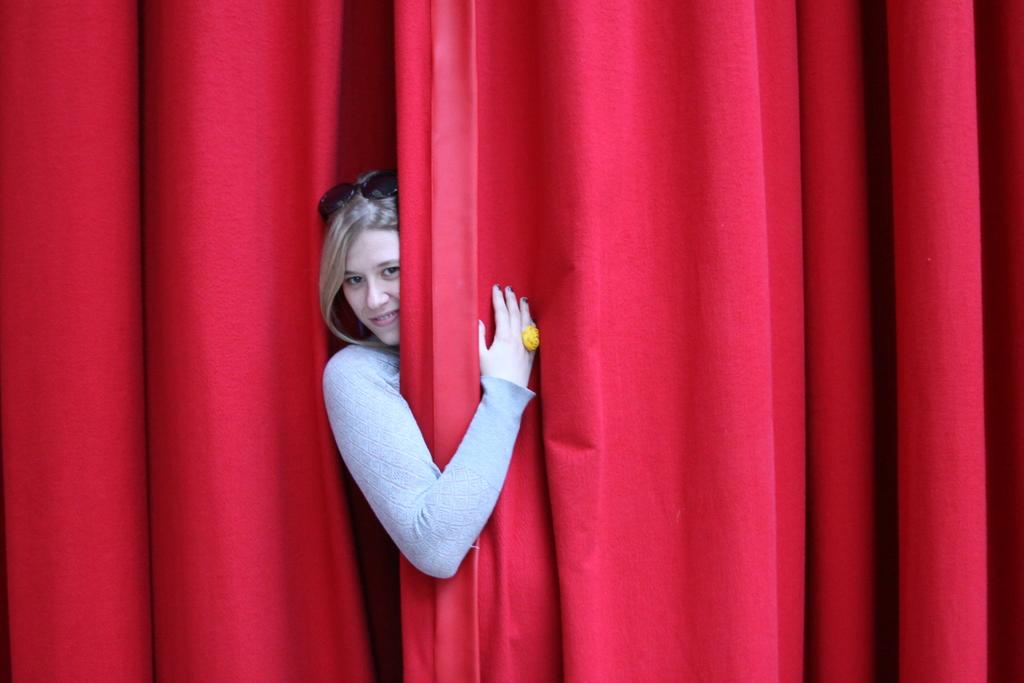Who is present in the image? There is a woman in the image. What is the woman wearing? The woman is wearing a grey dress. What is the woman's facial expression? The woman is smiling. What is the woman doing with her spectacles? The woman is wearing spectacles on her head. What is the color of the curtain behind the woman? The woman is behind a red color curtain. What type of bear can be seen comforting the woman in the image? There is no bear present in the image, and the woman is not being comforted by any creature. 